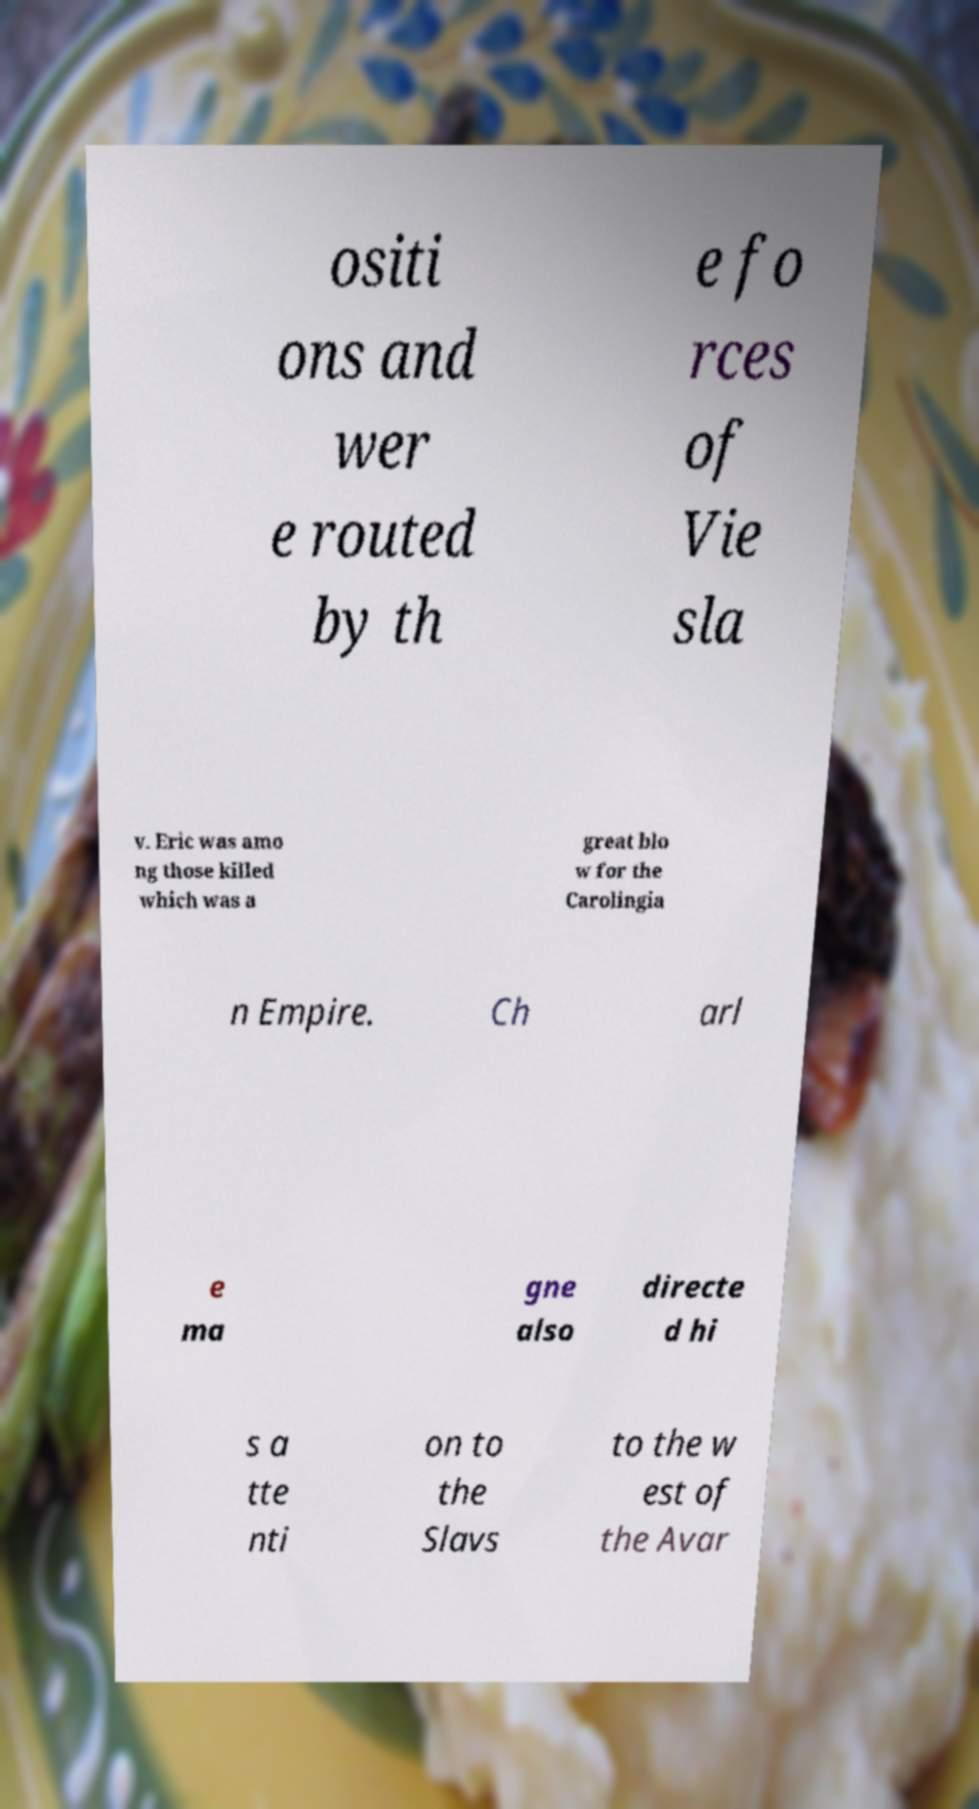Could you extract and type out the text from this image? ositi ons and wer e routed by th e fo rces of Vie sla v. Eric was amo ng those killed which was a great blo w for the Carolingia n Empire. Ch arl e ma gne also directe d hi s a tte nti on to the Slavs to the w est of the Avar 